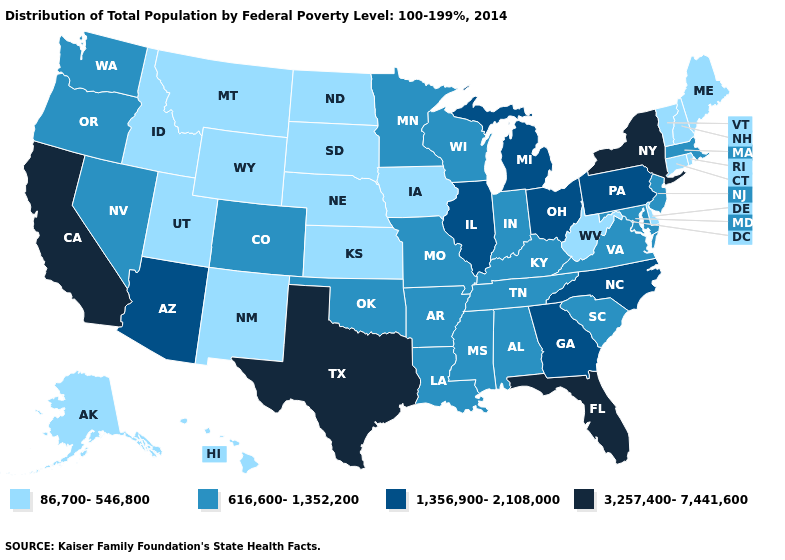Does Mississippi have the same value as Arizona?
Answer briefly. No. What is the highest value in the MidWest ?
Write a very short answer. 1,356,900-2,108,000. Does the first symbol in the legend represent the smallest category?
Concise answer only. Yes. Among the states that border Nebraska , does Kansas have the lowest value?
Be succinct. Yes. Does New Mexico have a lower value than Virginia?
Give a very brief answer. Yes. Which states have the lowest value in the USA?
Give a very brief answer. Alaska, Connecticut, Delaware, Hawaii, Idaho, Iowa, Kansas, Maine, Montana, Nebraska, New Hampshire, New Mexico, North Dakota, Rhode Island, South Dakota, Utah, Vermont, West Virginia, Wyoming. What is the lowest value in the USA?
Give a very brief answer. 86,700-546,800. Name the states that have a value in the range 86,700-546,800?
Short answer required. Alaska, Connecticut, Delaware, Hawaii, Idaho, Iowa, Kansas, Maine, Montana, Nebraska, New Hampshire, New Mexico, North Dakota, Rhode Island, South Dakota, Utah, Vermont, West Virginia, Wyoming. Name the states that have a value in the range 86,700-546,800?
Write a very short answer. Alaska, Connecticut, Delaware, Hawaii, Idaho, Iowa, Kansas, Maine, Montana, Nebraska, New Hampshire, New Mexico, North Dakota, Rhode Island, South Dakota, Utah, Vermont, West Virginia, Wyoming. Does Georgia have a higher value than Florida?
Answer briefly. No. Does the first symbol in the legend represent the smallest category?
Short answer required. Yes. How many symbols are there in the legend?
Be succinct. 4. What is the value of Iowa?
Short answer required. 86,700-546,800. What is the lowest value in the USA?
Quick response, please. 86,700-546,800. Name the states that have a value in the range 3,257,400-7,441,600?
Answer briefly. California, Florida, New York, Texas. 